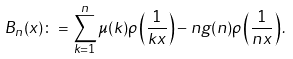Convert formula to latex. <formula><loc_0><loc_0><loc_500><loc_500>B _ { n } ( x ) \colon = \sum _ { k = 1 } ^ { n } \mu ( k ) \rho \left ( \frac { 1 } { k x } \right ) - n g ( n ) \rho \left ( \frac { 1 } { n x } \right ) .</formula> 